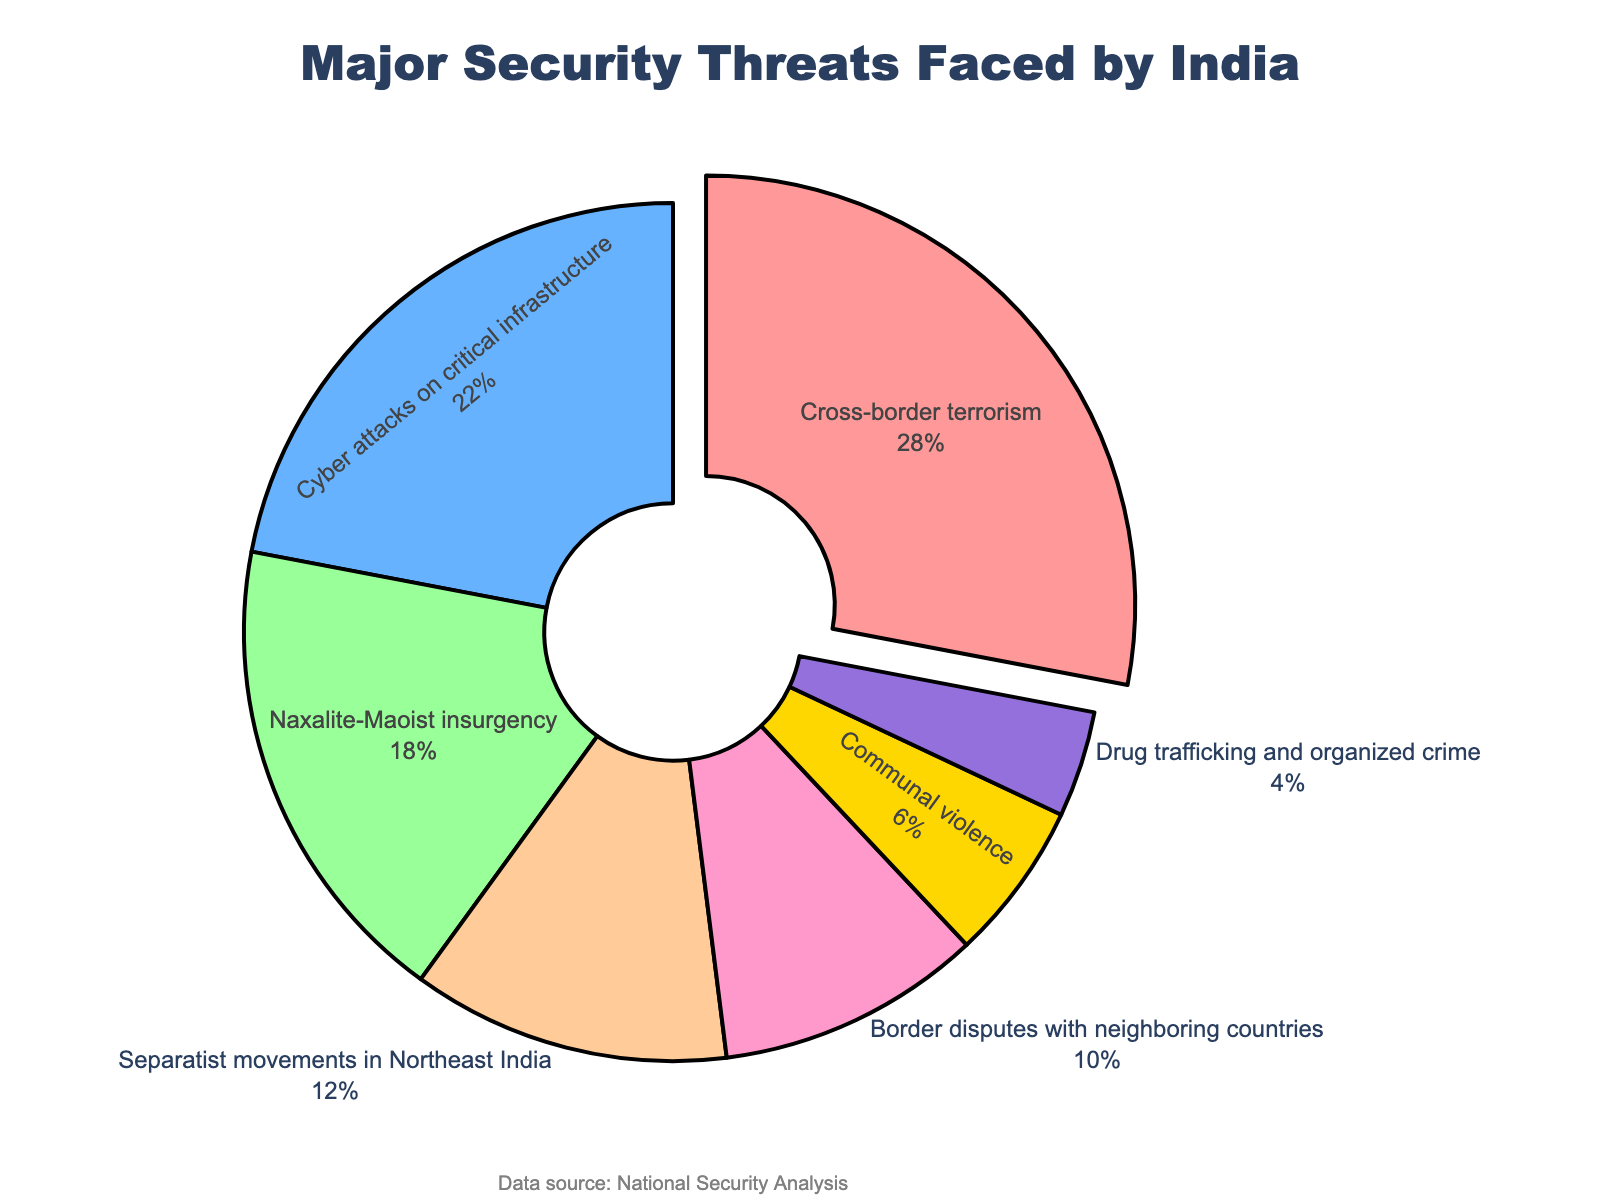What's the most significant security threat faced by India? The pie chart shows that the largest portion of the chart is dedicated to "Cross-border terrorism" which represents 28% of the total security threats.
Answer: Cross-border terrorism How much percentage do cyber attacks and drug trafficking combined make up? The percentage of cyber attacks on critical infrastructure is 22%, and the percentage of drug trafficking and organized crime is 4%. Adding them together gives 22% + 4% = 26%.
Answer: 26% Which security threat accounts for the smallest portion and what percentage does it represent? The pie chart shows that "Drug trafficking and organized crime" occupy the smallest segment, which is 4%.
Answer: Drug trafficking and organized crime, 4% What is the color used to represent the 'Naxalite-Maoist insurgency'? In the pie chart, the 'Naxalite-Maoist insurgency' is represented by the green segment.
Answer: Green Is the percentage of separatist movements in Northeast India greater than or less than communal violence? The separatist movements in Northeast India account for 12%, while communal violence accounts for 6%. Therefore, 12% is greater than 6%.
Answer: Greater What is the difference in percentage between border disputes with neighboring countries and communal violence? The percentage for border disputes with neighboring countries is 10%, and for communal violence, it is 6%. The difference is 10% - 6% = 4%.
Answer: 4% Combine the percentages of the three least significant threats. What are they and what's the total? The three least significant threats are 'Communal violence' (6%), 'Border disputes with neighboring countries' (10%), and 'Drug trafficking and organized crime' (4%). Summing them up gives 6% + 10% + 4% = 20%.
Answer: Communal violence, Border disputes with neighboring countries, Drug trafficking and organized crime; 20% Which threat is pulled out slightly from the rest in the pie chart, and why is this done? The 'Cross-border terrorism' segment is pulled out slightly from the rest, which emphasizes that it is the most significant threat, representing the largest percentage (28%).
Answer: Cross-border terrorism, to highlight its significance 